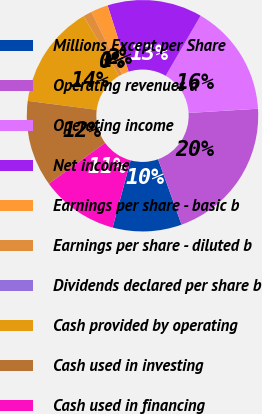Convert chart to OTSL. <chart><loc_0><loc_0><loc_500><loc_500><pie_chart><fcel>Millions Except per Share<fcel>Operating revenues a<fcel>Operating income<fcel>Net income<fcel>Earnings per share - basic b<fcel>Earnings per share - diluted b<fcel>Dividends declared per share b<fcel>Cash provided by operating<fcel>Cash used in investing<fcel>Cash used in financing<nl><fcel>9.64%<fcel>20.48%<fcel>15.66%<fcel>13.25%<fcel>2.41%<fcel>1.2%<fcel>0.0%<fcel>14.46%<fcel>12.05%<fcel>10.84%<nl></chart> 